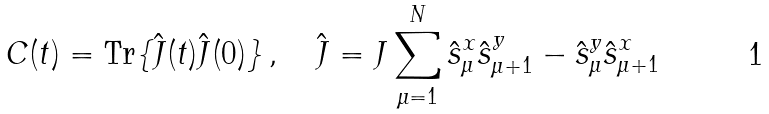Convert formula to latex. <formula><loc_0><loc_0><loc_500><loc_500>C ( t ) = \text {Tr} \{ \hat { J } ( t ) \hat { J } ( 0 ) \} \, , \quad \hat { J } = J \sum _ { \mu = 1 } ^ { N } \hat { s } _ { \mu } ^ { x } \hat { s } _ { \mu + 1 } ^ { y } - \hat { s } _ { \mu } ^ { y } \hat { s } _ { \mu + 1 } ^ { x }</formula> 